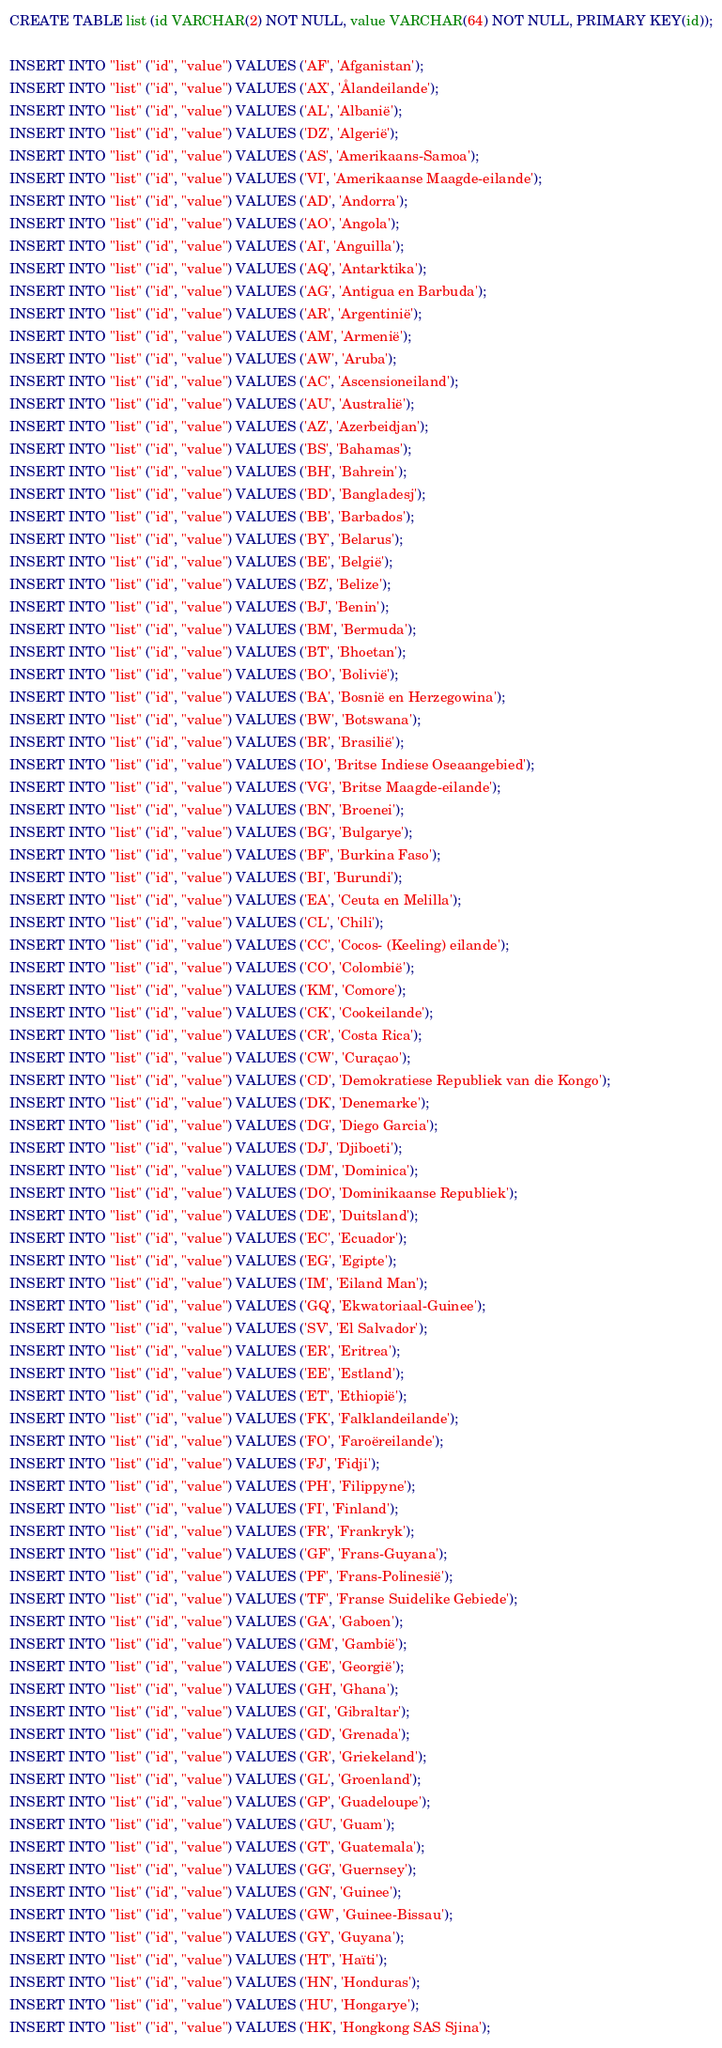<code> <loc_0><loc_0><loc_500><loc_500><_SQL_>CREATE TABLE list (id VARCHAR(2) NOT NULL, value VARCHAR(64) NOT NULL, PRIMARY KEY(id));

INSERT INTO "list" ("id", "value") VALUES ('AF', 'Afganistan');
INSERT INTO "list" ("id", "value") VALUES ('AX', 'Ålandeilande');
INSERT INTO "list" ("id", "value") VALUES ('AL', 'Albanië');
INSERT INTO "list" ("id", "value") VALUES ('DZ', 'Algerië');
INSERT INTO "list" ("id", "value") VALUES ('AS', 'Amerikaans-Samoa');
INSERT INTO "list" ("id", "value") VALUES ('VI', 'Amerikaanse Maagde-eilande');
INSERT INTO "list" ("id", "value") VALUES ('AD', 'Andorra');
INSERT INTO "list" ("id", "value") VALUES ('AO', 'Angola');
INSERT INTO "list" ("id", "value") VALUES ('AI', 'Anguilla');
INSERT INTO "list" ("id", "value") VALUES ('AQ', 'Antarktika');
INSERT INTO "list" ("id", "value") VALUES ('AG', 'Antigua en Barbuda');
INSERT INTO "list" ("id", "value") VALUES ('AR', 'Argentinië');
INSERT INTO "list" ("id", "value") VALUES ('AM', 'Armenië');
INSERT INTO "list" ("id", "value") VALUES ('AW', 'Aruba');
INSERT INTO "list" ("id", "value") VALUES ('AC', 'Ascensioneiland');
INSERT INTO "list" ("id", "value") VALUES ('AU', 'Australië');
INSERT INTO "list" ("id", "value") VALUES ('AZ', 'Azerbeidjan');
INSERT INTO "list" ("id", "value") VALUES ('BS', 'Bahamas');
INSERT INTO "list" ("id", "value") VALUES ('BH', 'Bahrein');
INSERT INTO "list" ("id", "value") VALUES ('BD', 'Bangladesj');
INSERT INTO "list" ("id", "value") VALUES ('BB', 'Barbados');
INSERT INTO "list" ("id", "value") VALUES ('BY', 'Belarus');
INSERT INTO "list" ("id", "value") VALUES ('BE', 'België');
INSERT INTO "list" ("id", "value") VALUES ('BZ', 'Belize');
INSERT INTO "list" ("id", "value") VALUES ('BJ', 'Benin');
INSERT INTO "list" ("id", "value") VALUES ('BM', 'Bermuda');
INSERT INTO "list" ("id", "value") VALUES ('BT', 'Bhoetan');
INSERT INTO "list" ("id", "value") VALUES ('BO', 'Bolivië');
INSERT INTO "list" ("id", "value") VALUES ('BA', 'Bosnië en Herzegowina');
INSERT INTO "list" ("id", "value") VALUES ('BW', 'Botswana');
INSERT INTO "list" ("id", "value") VALUES ('BR', 'Brasilië');
INSERT INTO "list" ("id", "value") VALUES ('IO', 'Britse Indiese Oseaangebied');
INSERT INTO "list" ("id", "value") VALUES ('VG', 'Britse Maagde-eilande');
INSERT INTO "list" ("id", "value") VALUES ('BN', 'Broenei');
INSERT INTO "list" ("id", "value") VALUES ('BG', 'Bulgarye');
INSERT INTO "list" ("id", "value") VALUES ('BF', 'Burkina Faso');
INSERT INTO "list" ("id", "value") VALUES ('BI', 'Burundi');
INSERT INTO "list" ("id", "value") VALUES ('EA', 'Ceuta en Melilla');
INSERT INTO "list" ("id", "value") VALUES ('CL', 'Chili');
INSERT INTO "list" ("id", "value") VALUES ('CC', 'Cocos- (Keeling) eilande');
INSERT INTO "list" ("id", "value") VALUES ('CO', 'Colombië');
INSERT INTO "list" ("id", "value") VALUES ('KM', 'Comore');
INSERT INTO "list" ("id", "value") VALUES ('CK', 'Cookeilande');
INSERT INTO "list" ("id", "value") VALUES ('CR', 'Costa Rica');
INSERT INTO "list" ("id", "value") VALUES ('CW', 'Curaçao');
INSERT INTO "list" ("id", "value") VALUES ('CD', 'Demokratiese Republiek van die Kongo');
INSERT INTO "list" ("id", "value") VALUES ('DK', 'Denemarke');
INSERT INTO "list" ("id", "value") VALUES ('DG', 'Diego Garcia');
INSERT INTO "list" ("id", "value") VALUES ('DJ', 'Djiboeti');
INSERT INTO "list" ("id", "value") VALUES ('DM', 'Dominica');
INSERT INTO "list" ("id", "value") VALUES ('DO', 'Dominikaanse Republiek');
INSERT INTO "list" ("id", "value") VALUES ('DE', 'Duitsland');
INSERT INTO "list" ("id", "value") VALUES ('EC', 'Ecuador');
INSERT INTO "list" ("id", "value") VALUES ('EG', 'Egipte');
INSERT INTO "list" ("id", "value") VALUES ('IM', 'Eiland Man');
INSERT INTO "list" ("id", "value") VALUES ('GQ', 'Ekwatoriaal-Guinee');
INSERT INTO "list" ("id", "value") VALUES ('SV', 'El Salvador');
INSERT INTO "list" ("id", "value") VALUES ('ER', 'Eritrea');
INSERT INTO "list" ("id", "value") VALUES ('EE', 'Estland');
INSERT INTO "list" ("id", "value") VALUES ('ET', 'Ethiopië');
INSERT INTO "list" ("id", "value") VALUES ('FK', 'Falklandeilande');
INSERT INTO "list" ("id", "value") VALUES ('FO', 'Faroëreilande');
INSERT INTO "list" ("id", "value") VALUES ('FJ', 'Fidji');
INSERT INTO "list" ("id", "value") VALUES ('PH', 'Filippyne');
INSERT INTO "list" ("id", "value") VALUES ('FI', 'Finland');
INSERT INTO "list" ("id", "value") VALUES ('FR', 'Frankryk');
INSERT INTO "list" ("id", "value") VALUES ('GF', 'Frans-Guyana');
INSERT INTO "list" ("id", "value") VALUES ('PF', 'Frans-Polinesië');
INSERT INTO "list" ("id", "value") VALUES ('TF', 'Franse Suidelike Gebiede');
INSERT INTO "list" ("id", "value") VALUES ('GA', 'Gaboen');
INSERT INTO "list" ("id", "value") VALUES ('GM', 'Gambië');
INSERT INTO "list" ("id", "value") VALUES ('GE', 'Georgië');
INSERT INTO "list" ("id", "value") VALUES ('GH', 'Ghana');
INSERT INTO "list" ("id", "value") VALUES ('GI', 'Gibraltar');
INSERT INTO "list" ("id", "value") VALUES ('GD', 'Grenada');
INSERT INTO "list" ("id", "value") VALUES ('GR', 'Griekeland');
INSERT INTO "list" ("id", "value") VALUES ('GL', 'Groenland');
INSERT INTO "list" ("id", "value") VALUES ('GP', 'Guadeloupe');
INSERT INTO "list" ("id", "value") VALUES ('GU', 'Guam');
INSERT INTO "list" ("id", "value") VALUES ('GT', 'Guatemala');
INSERT INTO "list" ("id", "value") VALUES ('GG', 'Guernsey');
INSERT INTO "list" ("id", "value") VALUES ('GN', 'Guinee');
INSERT INTO "list" ("id", "value") VALUES ('GW', 'Guinee-Bissau');
INSERT INTO "list" ("id", "value") VALUES ('GY', 'Guyana');
INSERT INTO "list" ("id", "value") VALUES ('HT', 'Haïti');
INSERT INTO "list" ("id", "value") VALUES ('HN', 'Honduras');
INSERT INTO "list" ("id", "value") VALUES ('HU', 'Hongarye');
INSERT INTO "list" ("id", "value") VALUES ('HK', 'Hongkong SAS Sjina');</code> 